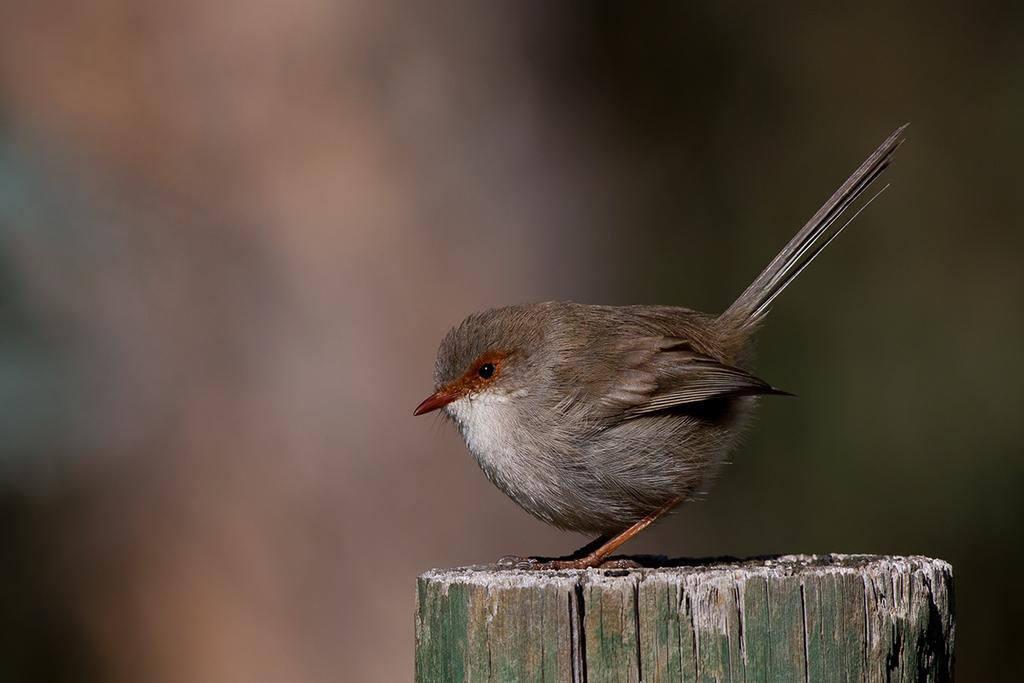What is the main subject of the image? There is a bird in the middle of the image. Can you describe the bird in the image? The bird is the main focus of the image, but no specific details about its appearance or behavior are provided. What might the bird be doing in the image? Without additional information, it is impossible to determine what the bird is doing in the image. What type of drug is the bird using in the image? There is no drug present in the image, as it features a bird. 